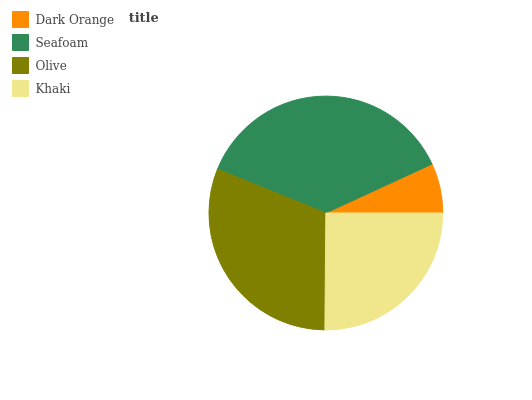Is Dark Orange the minimum?
Answer yes or no. Yes. Is Seafoam the maximum?
Answer yes or no. Yes. Is Olive the minimum?
Answer yes or no. No. Is Olive the maximum?
Answer yes or no. No. Is Seafoam greater than Olive?
Answer yes or no. Yes. Is Olive less than Seafoam?
Answer yes or no. Yes. Is Olive greater than Seafoam?
Answer yes or no. No. Is Seafoam less than Olive?
Answer yes or no. No. Is Olive the high median?
Answer yes or no. Yes. Is Khaki the low median?
Answer yes or no. Yes. Is Dark Orange the high median?
Answer yes or no. No. Is Olive the low median?
Answer yes or no. No. 